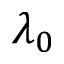Convert formula to latex. <formula><loc_0><loc_0><loc_500><loc_500>\lambda _ { 0 }</formula> 